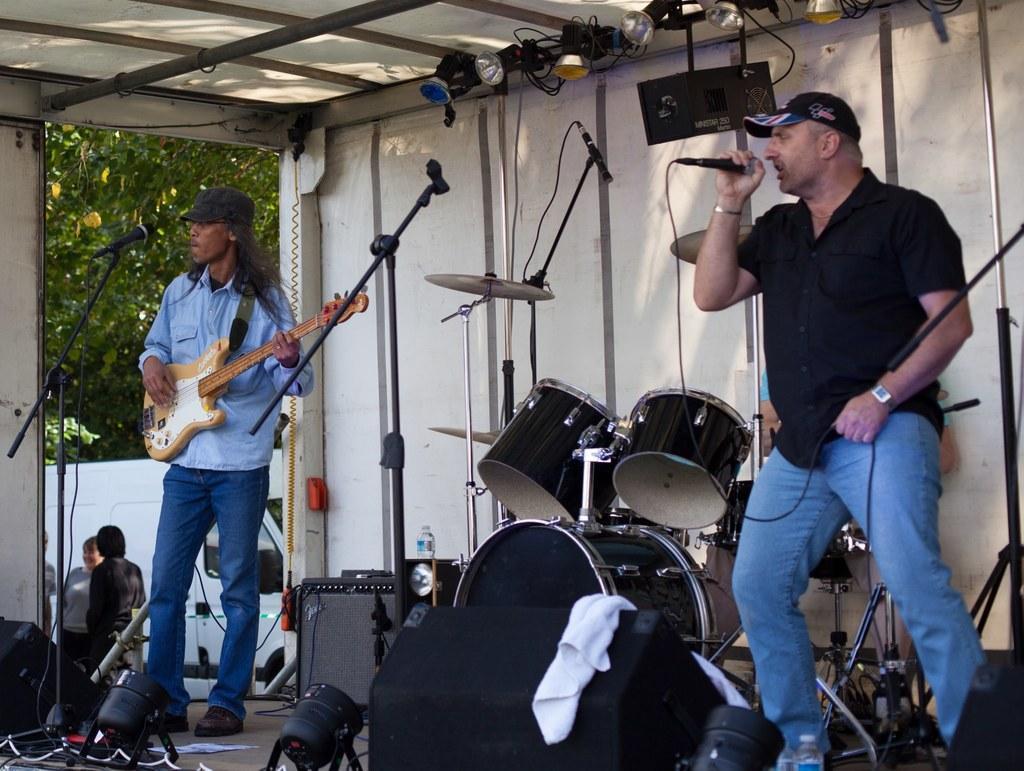In one or two sentences, can you explain what this image depicts? In this picture we can see two men where one is playing guitar and other is singing on mic and in between them we can see drums, speakers, lights, cloth, bottle and in background we can see trees, wall, some persons. 